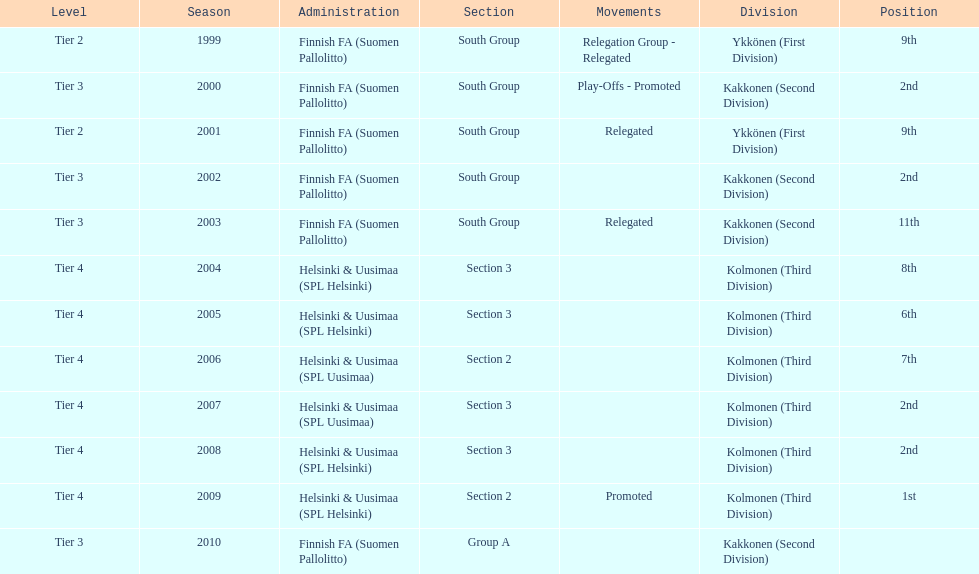How many 2nd positions were there? 4. 